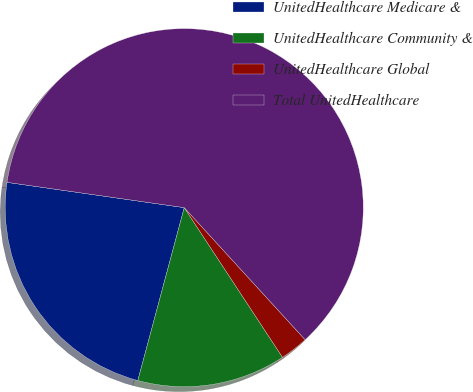Convert chart to OTSL. <chart><loc_0><loc_0><loc_500><loc_500><pie_chart><fcel>UnitedHealthcare Medicare &<fcel>UnitedHealthcare Community &<fcel>UnitedHealthcare Global<fcel>Total UnitedHealthcare<nl><fcel>23.08%<fcel>13.42%<fcel>2.55%<fcel>60.95%<nl></chart> 